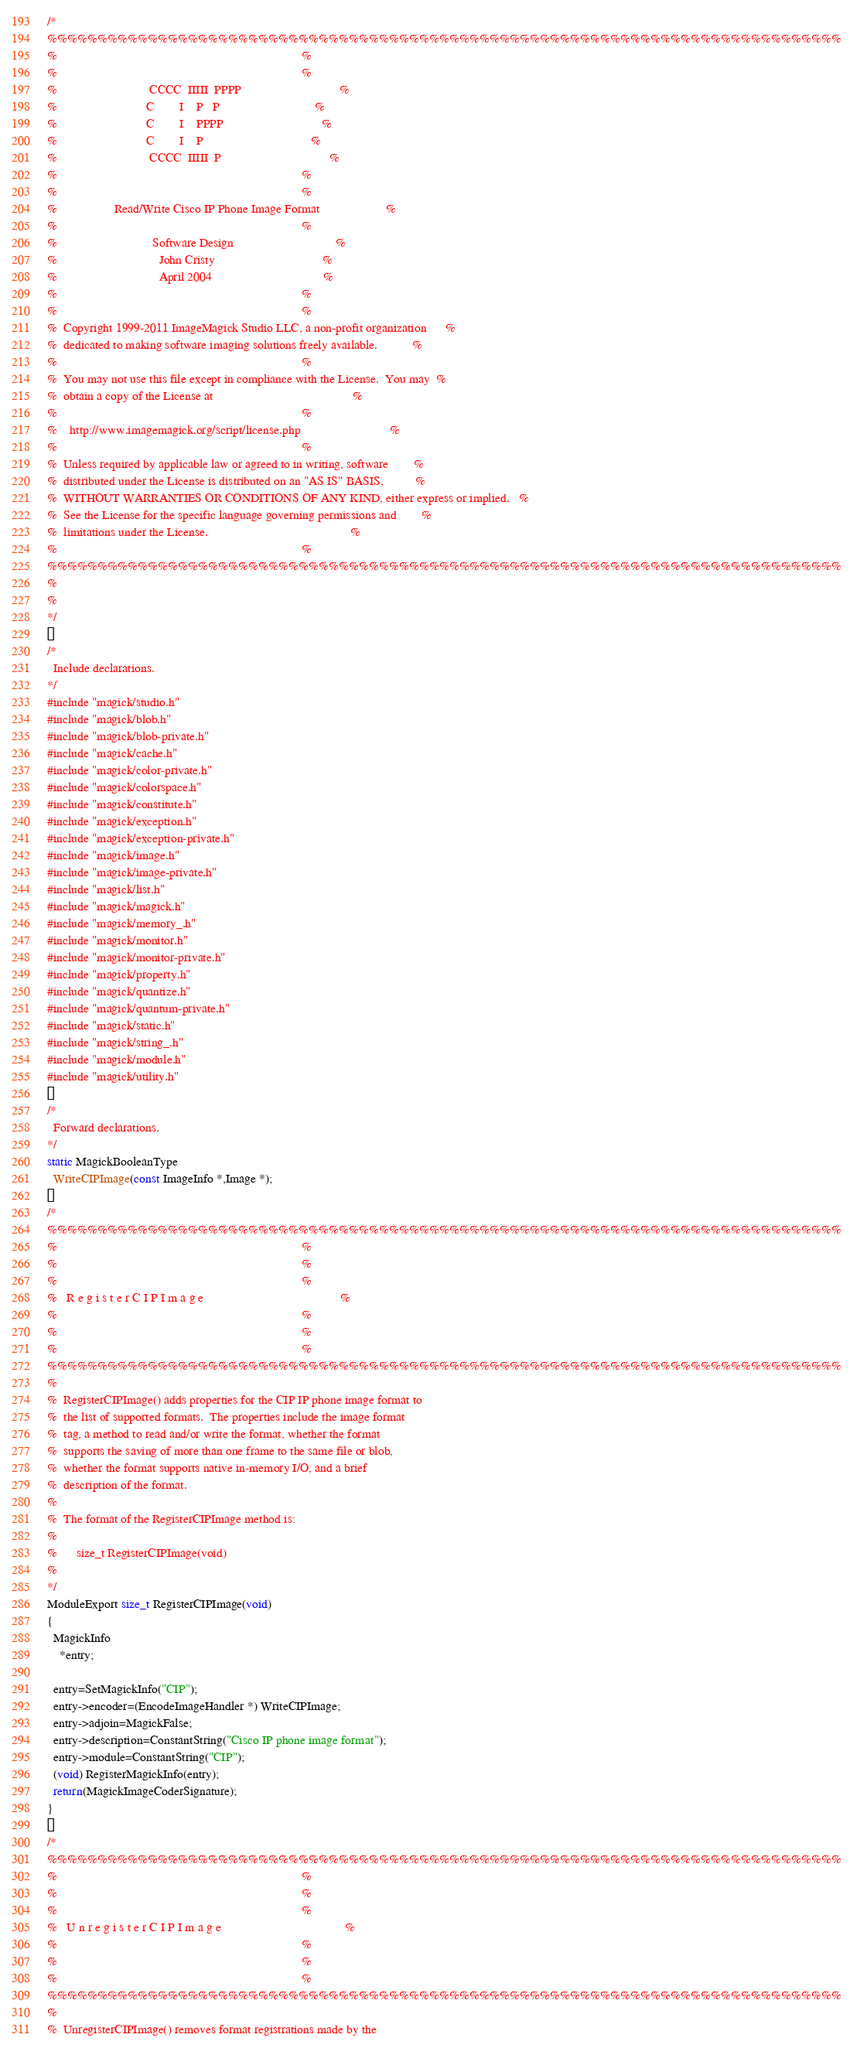Convert code to text. <code><loc_0><loc_0><loc_500><loc_500><_C_>/*
%%%%%%%%%%%%%%%%%%%%%%%%%%%%%%%%%%%%%%%%%%%%%%%%%%%%%%%%%%%%%%%%%%%%%%%%%%%%%%%
%                                                                             %
%                                                                             %
%                             CCCC  IIIII  PPPP                               %
%                            C        I    P   P                              %
%                            C        I    PPPP                               %
%                            C        I    P                                  %
%                             CCCC  IIIII  P                                  %
%                                                                             %
%                                                                             %
%                  Read/Write Cisco IP Phone Image Format                     %
%                                                                             %
%                              Software Design                                %
%                                John Cristy                                  %
%                                April 2004                                   %
%                                                                             %
%                                                                             %
%  Copyright 1999-2011 ImageMagick Studio LLC, a non-profit organization      %
%  dedicated to making software imaging solutions freely available.           %
%                                                                             %
%  You may not use this file except in compliance with the License.  You may  %
%  obtain a copy of the License at                                            %
%                                                                             %
%    http://www.imagemagick.org/script/license.php                            %
%                                                                             %
%  Unless required by applicable law or agreed to in writing, software        %
%  distributed under the License is distributed on an "AS IS" BASIS,          %
%  WITHOUT WARRANTIES OR CONDITIONS OF ANY KIND, either express or implied.   %
%  See the License for the specific language governing permissions and        %
%  limitations under the License.                                             %
%                                                                             %
%%%%%%%%%%%%%%%%%%%%%%%%%%%%%%%%%%%%%%%%%%%%%%%%%%%%%%%%%%%%%%%%%%%%%%%%%%%%%%%
%
%
*/

/*
  Include declarations.
*/
#include "magick/studio.h"
#include "magick/blob.h"
#include "magick/blob-private.h"
#include "magick/cache.h"
#include "magick/color-private.h"
#include "magick/colorspace.h"
#include "magick/constitute.h"
#include "magick/exception.h"
#include "magick/exception-private.h"
#include "magick/image.h"
#include "magick/image-private.h"
#include "magick/list.h"
#include "magick/magick.h"
#include "magick/memory_.h"
#include "magick/monitor.h"
#include "magick/monitor-private.h"
#include "magick/property.h"
#include "magick/quantize.h"
#include "magick/quantum-private.h"
#include "magick/static.h"
#include "magick/string_.h"
#include "magick/module.h"
#include "magick/utility.h"

/*
  Forward declarations.
*/
static MagickBooleanType
  WriteCIPImage(const ImageInfo *,Image *);

/*
%%%%%%%%%%%%%%%%%%%%%%%%%%%%%%%%%%%%%%%%%%%%%%%%%%%%%%%%%%%%%%%%%%%%%%%%%%%%%%%
%                                                                             %
%                                                                             %
%                                                                             %
%   R e g i s t e r C I P I m a g e                                           %
%                                                                             %
%                                                                             %
%                                                                             %
%%%%%%%%%%%%%%%%%%%%%%%%%%%%%%%%%%%%%%%%%%%%%%%%%%%%%%%%%%%%%%%%%%%%%%%%%%%%%%%
%
%  RegisterCIPImage() adds properties for the CIP IP phone image format to
%  the list of supported formats.  The properties include the image format
%  tag, a method to read and/or write the format, whether the format
%  supports the saving of more than one frame to the same file or blob,
%  whether the format supports native in-memory I/O, and a brief
%  description of the format.
%
%  The format of the RegisterCIPImage method is:
%
%      size_t RegisterCIPImage(void)
%
*/
ModuleExport size_t RegisterCIPImage(void)
{
  MagickInfo
    *entry;

  entry=SetMagickInfo("CIP");
  entry->encoder=(EncodeImageHandler *) WriteCIPImage;
  entry->adjoin=MagickFalse;
  entry->description=ConstantString("Cisco IP phone image format");
  entry->module=ConstantString("CIP");
  (void) RegisterMagickInfo(entry);
  return(MagickImageCoderSignature);
}

/*
%%%%%%%%%%%%%%%%%%%%%%%%%%%%%%%%%%%%%%%%%%%%%%%%%%%%%%%%%%%%%%%%%%%%%%%%%%%%%%%
%                                                                             %
%                                                                             %
%                                                                             %
%   U n r e g i s t e r C I P I m a g e                                       %
%                                                                             %
%                                                                             %
%                                                                             %
%%%%%%%%%%%%%%%%%%%%%%%%%%%%%%%%%%%%%%%%%%%%%%%%%%%%%%%%%%%%%%%%%%%%%%%%%%%%%%%
%
%  UnregisterCIPImage() removes format registrations made by the</code> 